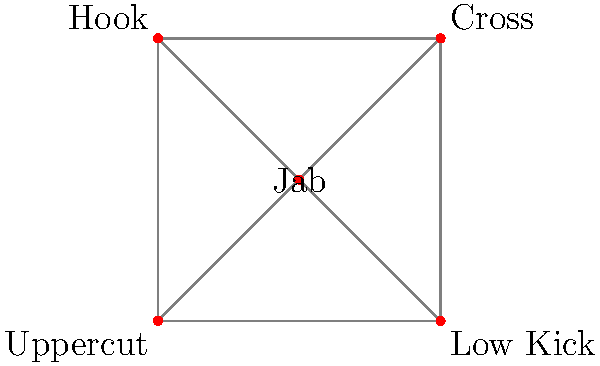In the graph theory representation of kickboxing stances and transitions, each vertex represents a specific strike, and edges represent possible transitions between strikes. Given the network shown, what is the minimum number of edges that need to be removed to disconnect the "Jab" vertex from the "Low Kick" vertex? To solve this problem, we need to find the minimum number of edge-disjoint paths between the "Jab" and "Low Kick" vertices. This is equivalent to finding the max-flow or the minimum cut between these two vertices.

Step 1: Identify all possible paths from "Jab" to "Low Kick":
1. Jab → Low Kick
2. Jab → Cross → Low Kick
3. Jab → Hook → Low Kick
4. Jab → Uppercut → Low Kick

Step 2: Observe that all these paths are edge-disjoint, meaning they don't share any common edges.

Step 3: Count the number of edge-disjoint paths. There are 4 such paths.

Step 4: According to Menger's theorem, the minimum number of edges that need to be removed to disconnect two vertices is equal to the maximum number of edge-disjoint paths between those vertices.

Therefore, we need to remove at least 4 edges to disconnect the "Jab" vertex from the "Low Kick" vertex.
Answer: 4 